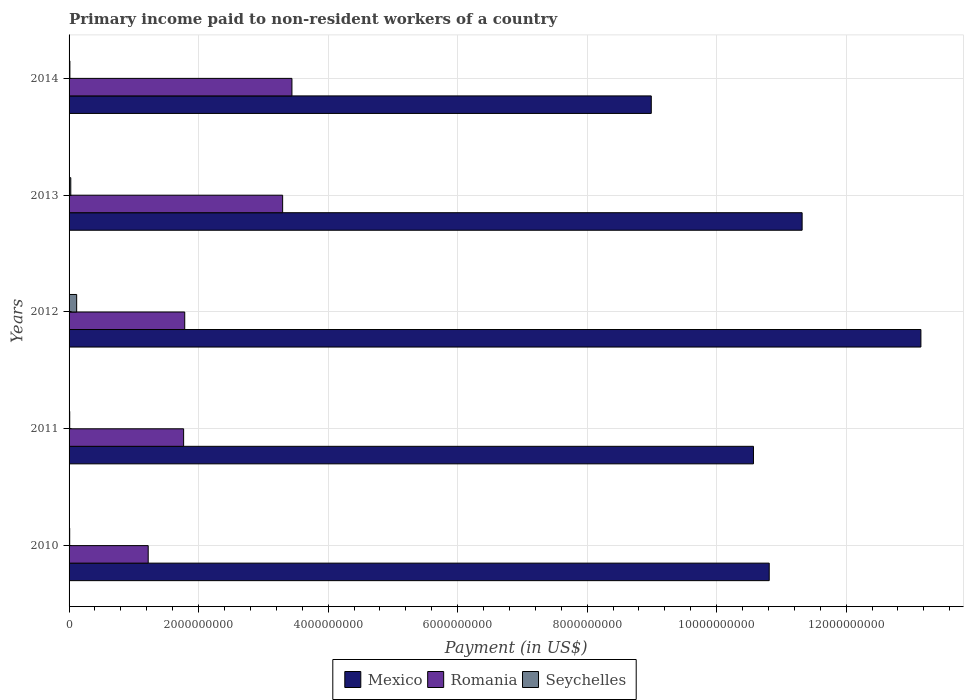How many different coloured bars are there?
Give a very brief answer. 3. How many groups of bars are there?
Offer a terse response. 5. Are the number of bars per tick equal to the number of legend labels?
Offer a very short reply. Yes. Are the number of bars on each tick of the Y-axis equal?
Make the answer very short. Yes. How many bars are there on the 1st tick from the top?
Provide a short and direct response. 3. How many bars are there on the 2nd tick from the bottom?
Offer a terse response. 3. What is the amount paid to workers in Seychelles in 2013?
Provide a succinct answer. 2.65e+07. Across all years, what is the maximum amount paid to workers in Mexico?
Offer a very short reply. 1.32e+1. Across all years, what is the minimum amount paid to workers in Mexico?
Make the answer very short. 8.99e+09. In which year was the amount paid to workers in Seychelles minimum?
Give a very brief answer. 2010. What is the total amount paid to workers in Seychelles in the graph?
Your answer should be very brief. 1.76e+08. What is the difference between the amount paid to workers in Romania in 2010 and that in 2012?
Offer a terse response. -5.64e+08. What is the difference between the amount paid to workers in Romania in 2010 and the amount paid to workers in Mexico in 2011?
Offer a terse response. -9.35e+09. What is the average amount paid to workers in Romania per year?
Your answer should be compact. 2.30e+09. In the year 2014, what is the difference between the amount paid to workers in Seychelles and amount paid to workers in Romania?
Provide a short and direct response. -3.43e+09. What is the ratio of the amount paid to workers in Mexico in 2011 to that in 2012?
Offer a terse response. 0.8. Is the amount paid to workers in Mexico in 2010 less than that in 2013?
Your answer should be very brief. Yes. What is the difference between the highest and the second highest amount paid to workers in Romania?
Offer a very short reply. 1.44e+08. What is the difference between the highest and the lowest amount paid to workers in Seychelles?
Give a very brief answer. 1.08e+08. Is the sum of the amount paid to workers in Mexico in 2010 and 2013 greater than the maximum amount paid to workers in Seychelles across all years?
Your response must be concise. Yes. What does the 2nd bar from the bottom in 2013 represents?
Keep it short and to the point. Romania. How many years are there in the graph?
Provide a short and direct response. 5. What is the difference between two consecutive major ticks on the X-axis?
Keep it short and to the point. 2.00e+09. Does the graph contain grids?
Give a very brief answer. Yes. How are the legend labels stacked?
Provide a short and direct response. Horizontal. What is the title of the graph?
Make the answer very short. Primary income paid to non-resident workers of a country. What is the label or title of the X-axis?
Your answer should be compact. Payment (in US$). What is the label or title of the Y-axis?
Offer a very short reply. Years. What is the Payment (in US$) of Mexico in 2010?
Make the answer very short. 1.08e+1. What is the Payment (in US$) in Romania in 2010?
Offer a very short reply. 1.22e+09. What is the Payment (in US$) in Seychelles in 2010?
Your answer should be compact. 9.57e+06. What is the Payment (in US$) of Mexico in 2011?
Your answer should be compact. 1.06e+1. What is the Payment (in US$) of Romania in 2011?
Your answer should be very brief. 1.77e+09. What is the Payment (in US$) in Seychelles in 2011?
Your answer should be compact. 9.97e+06. What is the Payment (in US$) of Mexico in 2012?
Provide a short and direct response. 1.32e+1. What is the Payment (in US$) of Romania in 2012?
Make the answer very short. 1.79e+09. What is the Payment (in US$) of Seychelles in 2012?
Provide a short and direct response. 1.17e+08. What is the Payment (in US$) of Mexico in 2013?
Ensure brevity in your answer.  1.13e+1. What is the Payment (in US$) of Romania in 2013?
Ensure brevity in your answer.  3.30e+09. What is the Payment (in US$) of Seychelles in 2013?
Your answer should be very brief. 2.65e+07. What is the Payment (in US$) of Mexico in 2014?
Provide a succinct answer. 8.99e+09. What is the Payment (in US$) in Romania in 2014?
Make the answer very short. 3.44e+09. What is the Payment (in US$) in Seychelles in 2014?
Make the answer very short. 1.26e+07. Across all years, what is the maximum Payment (in US$) in Mexico?
Your answer should be very brief. 1.32e+1. Across all years, what is the maximum Payment (in US$) in Romania?
Your response must be concise. 3.44e+09. Across all years, what is the maximum Payment (in US$) of Seychelles?
Your answer should be compact. 1.17e+08. Across all years, what is the minimum Payment (in US$) of Mexico?
Your response must be concise. 8.99e+09. Across all years, what is the minimum Payment (in US$) in Romania?
Provide a succinct answer. 1.22e+09. Across all years, what is the minimum Payment (in US$) in Seychelles?
Make the answer very short. 9.57e+06. What is the total Payment (in US$) in Mexico in the graph?
Ensure brevity in your answer.  5.48e+1. What is the total Payment (in US$) in Romania in the graph?
Keep it short and to the point. 1.15e+1. What is the total Payment (in US$) in Seychelles in the graph?
Your answer should be very brief. 1.76e+08. What is the difference between the Payment (in US$) in Mexico in 2010 and that in 2011?
Give a very brief answer. 2.43e+08. What is the difference between the Payment (in US$) in Romania in 2010 and that in 2011?
Keep it short and to the point. -5.47e+08. What is the difference between the Payment (in US$) of Seychelles in 2010 and that in 2011?
Make the answer very short. -4.01e+05. What is the difference between the Payment (in US$) in Mexico in 2010 and that in 2012?
Give a very brief answer. -2.34e+09. What is the difference between the Payment (in US$) of Romania in 2010 and that in 2012?
Offer a terse response. -5.64e+08. What is the difference between the Payment (in US$) of Seychelles in 2010 and that in 2012?
Make the answer very short. -1.08e+08. What is the difference between the Payment (in US$) of Mexico in 2010 and that in 2013?
Provide a short and direct response. -5.08e+08. What is the difference between the Payment (in US$) in Romania in 2010 and that in 2013?
Make the answer very short. -2.08e+09. What is the difference between the Payment (in US$) in Seychelles in 2010 and that in 2013?
Make the answer very short. -1.69e+07. What is the difference between the Payment (in US$) in Mexico in 2010 and that in 2014?
Provide a succinct answer. 1.82e+09. What is the difference between the Payment (in US$) in Romania in 2010 and that in 2014?
Your answer should be very brief. -2.22e+09. What is the difference between the Payment (in US$) in Seychelles in 2010 and that in 2014?
Offer a terse response. -3.07e+06. What is the difference between the Payment (in US$) in Mexico in 2011 and that in 2012?
Your answer should be very brief. -2.59e+09. What is the difference between the Payment (in US$) of Romania in 2011 and that in 2012?
Ensure brevity in your answer.  -1.70e+07. What is the difference between the Payment (in US$) of Seychelles in 2011 and that in 2012?
Ensure brevity in your answer.  -1.07e+08. What is the difference between the Payment (in US$) in Mexico in 2011 and that in 2013?
Provide a succinct answer. -7.51e+08. What is the difference between the Payment (in US$) in Romania in 2011 and that in 2013?
Provide a short and direct response. -1.53e+09. What is the difference between the Payment (in US$) of Seychelles in 2011 and that in 2013?
Your answer should be very brief. -1.65e+07. What is the difference between the Payment (in US$) of Mexico in 2011 and that in 2014?
Make the answer very short. 1.58e+09. What is the difference between the Payment (in US$) of Romania in 2011 and that in 2014?
Your answer should be compact. -1.67e+09. What is the difference between the Payment (in US$) of Seychelles in 2011 and that in 2014?
Offer a terse response. -2.67e+06. What is the difference between the Payment (in US$) in Mexico in 2012 and that in 2013?
Provide a succinct answer. 1.83e+09. What is the difference between the Payment (in US$) in Romania in 2012 and that in 2013?
Keep it short and to the point. -1.51e+09. What is the difference between the Payment (in US$) of Seychelles in 2012 and that in 2013?
Your response must be concise. 9.10e+07. What is the difference between the Payment (in US$) in Mexico in 2012 and that in 2014?
Provide a short and direct response. 4.16e+09. What is the difference between the Payment (in US$) of Romania in 2012 and that in 2014?
Your response must be concise. -1.66e+09. What is the difference between the Payment (in US$) in Seychelles in 2012 and that in 2014?
Offer a very short reply. 1.05e+08. What is the difference between the Payment (in US$) in Mexico in 2013 and that in 2014?
Your answer should be very brief. 2.33e+09. What is the difference between the Payment (in US$) in Romania in 2013 and that in 2014?
Offer a terse response. -1.44e+08. What is the difference between the Payment (in US$) in Seychelles in 2013 and that in 2014?
Offer a very short reply. 1.39e+07. What is the difference between the Payment (in US$) in Mexico in 2010 and the Payment (in US$) in Romania in 2011?
Keep it short and to the point. 9.04e+09. What is the difference between the Payment (in US$) in Mexico in 2010 and the Payment (in US$) in Seychelles in 2011?
Provide a succinct answer. 1.08e+1. What is the difference between the Payment (in US$) of Romania in 2010 and the Payment (in US$) of Seychelles in 2011?
Your response must be concise. 1.21e+09. What is the difference between the Payment (in US$) in Mexico in 2010 and the Payment (in US$) in Romania in 2012?
Your answer should be compact. 9.03e+09. What is the difference between the Payment (in US$) in Mexico in 2010 and the Payment (in US$) in Seychelles in 2012?
Give a very brief answer. 1.07e+1. What is the difference between the Payment (in US$) of Romania in 2010 and the Payment (in US$) of Seychelles in 2012?
Keep it short and to the point. 1.10e+09. What is the difference between the Payment (in US$) in Mexico in 2010 and the Payment (in US$) in Romania in 2013?
Your response must be concise. 7.51e+09. What is the difference between the Payment (in US$) in Mexico in 2010 and the Payment (in US$) in Seychelles in 2013?
Provide a succinct answer. 1.08e+1. What is the difference between the Payment (in US$) in Romania in 2010 and the Payment (in US$) in Seychelles in 2013?
Your answer should be very brief. 1.20e+09. What is the difference between the Payment (in US$) of Mexico in 2010 and the Payment (in US$) of Romania in 2014?
Your answer should be compact. 7.37e+09. What is the difference between the Payment (in US$) of Mexico in 2010 and the Payment (in US$) of Seychelles in 2014?
Ensure brevity in your answer.  1.08e+1. What is the difference between the Payment (in US$) in Romania in 2010 and the Payment (in US$) in Seychelles in 2014?
Provide a succinct answer. 1.21e+09. What is the difference between the Payment (in US$) in Mexico in 2011 and the Payment (in US$) in Romania in 2012?
Ensure brevity in your answer.  8.78e+09. What is the difference between the Payment (in US$) in Mexico in 2011 and the Payment (in US$) in Seychelles in 2012?
Offer a terse response. 1.05e+1. What is the difference between the Payment (in US$) in Romania in 2011 and the Payment (in US$) in Seychelles in 2012?
Provide a succinct answer. 1.65e+09. What is the difference between the Payment (in US$) of Mexico in 2011 and the Payment (in US$) of Romania in 2013?
Provide a short and direct response. 7.27e+09. What is the difference between the Payment (in US$) in Mexico in 2011 and the Payment (in US$) in Seychelles in 2013?
Offer a terse response. 1.05e+1. What is the difference between the Payment (in US$) in Romania in 2011 and the Payment (in US$) in Seychelles in 2013?
Your answer should be very brief. 1.74e+09. What is the difference between the Payment (in US$) of Mexico in 2011 and the Payment (in US$) of Romania in 2014?
Ensure brevity in your answer.  7.13e+09. What is the difference between the Payment (in US$) in Mexico in 2011 and the Payment (in US$) in Seychelles in 2014?
Your answer should be compact. 1.06e+1. What is the difference between the Payment (in US$) in Romania in 2011 and the Payment (in US$) in Seychelles in 2014?
Provide a succinct answer. 1.76e+09. What is the difference between the Payment (in US$) in Mexico in 2012 and the Payment (in US$) in Romania in 2013?
Keep it short and to the point. 9.86e+09. What is the difference between the Payment (in US$) of Mexico in 2012 and the Payment (in US$) of Seychelles in 2013?
Provide a succinct answer. 1.31e+1. What is the difference between the Payment (in US$) of Romania in 2012 and the Payment (in US$) of Seychelles in 2013?
Offer a very short reply. 1.76e+09. What is the difference between the Payment (in US$) in Mexico in 2012 and the Payment (in US$) in Romania in 2014?
Your response must be concise. 9.71e+09. What is the difference between the Payment (in US$) in Mexico in 2012 and the Payment (in US$) in Seychelles in 2014?
Provide a succinct answer. 1.31e+1. What is the difference between the Payment (in US$) in Romania in 2012 and the Payment (in US$) in Seychelles in 2014?
Offer a very short reply. 1.77e+09. What is the difference between the Payment (in US$) in Mexico in 2013 and the Payment (in US$) in Romania in 2014?
Your response must be concise. 7.88e+09. What is the difference between the Payment (in US$) of Mexico in 2013 and the Payment (in US$) of Seychelles in 2014?
Give a very brief answer. 1.13e+1. What is the difference between the Payment (in US$) in Romania in 2013 and the Payment (in US$) in Seychelles in 2014?
Your answer should be compact. 3.29e+09. What is the average Payment (in US$) of Mexico per year?
Provide a short and direct response. 1.10e+1. What is the average Payment (in US$) in Romania per year?
Offer a very short reply. 2.30e+09. What is the average Payment (in US$) of Seychelles per year?
Make the answer very short. 3.52e+07. In the year 2010, what is the difference between the Payment (in US$) in Mexico and Payment (in US$) in Romania?
Provide a succinct answer. 9.59e+09. In the year 2010, what is the difference between the Payment (in US$) of Mexico and Payment (in US$) of Seychelles?
Ensure brevity in your answer.  1.08e+1. In the year 2010, what is the difference between the Payment (in US$) in Romania and Payment (in US$) in Seychelles?
Your answer should be very brief. 1.21e+09. In the year 2011, what is the difference between the Payment (in US$) of Mexico and Payment (in US$) of Romania?
Offer a very short reply. 8.80e+09. In the year 2011, what is the difference between the Payment (in US$) of Mexico and Payment (in US$) of Seychelles?
Your response must be concise. 1.06e+1. In the year 2011, what is the difference between the Payment (in US$) in Romania and Payment (in US$) in Seychelles?
Your response must be concise. 1.76e+09. In the year 2012, what is the difference between the Payment (in US$) of Mexico and Payment (in US$) of Romania?
Offer a terse response. 1.14e+1. In the year 2012, what is the difference between the Payment (in US$) in Mexico and Payment (in US$) in Seychelles?
Your response must be concise. 1.30e+1. In the year 2012, what is the difference between the Payment (in US$) of Romania and Payment (in US$) of Seychelles?
Your response must be concise. 1.67e+09. In the year 2013, what is the difference between the Payment (in US$) of Mexico and Payment (in US$) of Romania?
Provide a short and direct response. 8.02e+09. In the year 2013, what is the difference between the Payment (in US$) of Mexico and Payment (in US$) of Seychelles?
Make the answer very short. 1.13e+1. In the year 2013, what is the difference between the Payment (in US$) of Romania and Payment (in US$) of Seychelles?
Keep it short and to the point. 3.27e+09. In the year 2014, what is the difference between the Payment (in US$) of Mexico and Payment (in US$) of Romania?
Provide a short and direct response. 5.55e+09. In the year 2014, what is the difference between the Payment (in US$) of Mexico and Payment (in US$) of Seychelles?
Ensure brevity in your answer.  8.98e+09. In the year 2014, what is the difference between the Payment (in US$) of Romania and Payment (in US$) of Seychelles?
Keep it short and to the point. 3.43e+09. What is the ratio of the Payment (in US$) of Mexico in 2010 to that in 2011?
Make the answer very short. 1.02. What is the ratio of the Payment (in US$) of Romania in 2010 to that in 2011?
Your response must be concise. 0.69. What is the ratio of the Payment (in US$) of Seychelles in 2010 to that in 2011?
Keep it short and to the point. 0.96. What is the ratio of the Payment (in US$) in Mexico in 2010 to that in 2012?
Keep it short and to the point. 0.82. What is the ratio of the Payment (in US$) in Romania in 2010 to that in 2012?
Your answer should be compact. 0.68. What is the ratio of the Payment (in US$) in Seychelles in 2010 to that in 2012?
Provide a short and direct response. 0.08. What is the ratio of the Payment (in US$) of Mexico in 2010 to that in 2013?
Provide a short and direct response. 0.96. What is the ratio of the Payment (in US$) of Romania in 2010 to that in 2013?
Offer a very short reply. 0.37. What is the ratio of the Payment (in US$) in Seychelles in 2010 to that in 2013?
Make the answer very short. 0.36. What is the ratio of the Payment (in US$) in Mexico in 2010 to that in 2014?
Offer a very short reply. 1.2. What is the ratio of the Payment (in US$) in Romania in 2010 to that in 2014?
Offer a terse response. 0.36. What is the ratio of the Payment (in US$) in Seychelles in 2010 to that in 2014?
Give a very brief answer. 0.76. What is the ratio of the Payment (in US$) in Mexico in 2011 to that in 2012?
Provide a short and direct response. 0.8. What is the ratio of the Payment (in US$) of Romania in 2011 to that in 2012?
Provide a short and direct response. 0.99. What is the ratio of the Payment (in US$) in Seychelles in 2011 to that in 2012?
Keep it short and to the point. 0.08. What is the ratio of the Payment (in US$) in Mexico in 2011 to that in 2013?
Provide a succinct answer. 0.93. What is the ratio of the Payment (in US$) in Romania in 2011 to that in 2013?
Provide a succinct answer. 0.54. What is the ratio of the Payment (in US$) in Seychelles in 2011 to that in 2013?
Keep it short and to the point. 0.38. What is the ratio of the Payment (in US$) of Mexico in 2011 to that in 2014?
Provide a short and direct response. 1.18. What is the ratio of the Payment (in US$) of Romania in 2011 to that in 2014?
Your answer should be compact. 0.51. What is the ratio of the Payment (in US$) in Seychelles in 2011 to that in 2014?
Make the answer very short. 0.79. What is the ratio of the Payment (in US$) of Mexico in 2012 to that in 2013?
Keep it short and to the point. 1.16. What is the ratio of the Payment (in US$) of Romania in 2012 to that in 2013?
Offer a very short reply. 0.54. What is the ratio of the Payment (in US$) in Seychelles in 2012 to that in 2013?
Give a very brief answer. 4.43. What is the ratio of the Payment (in US$) in Mexico in 2012 to that in 2014?
Offer a terse response. 1.46. What is the ratio of the Payment (in US$) of Romania in 2012 to that in 2014?
Offer a very short reply. 0.52. What is the ratio of the Payment (in US$) in Seychelles in 2012 to that in 2014?
Your response must be concise. 9.29. What is the ratio of the Payment (in US$) in Mexico in 2013 to that in 2014?
Keep it short and to the point. 1.26. What is the ratio of the Payment (in US$) in Romania in 2013 to that in 2014?
Ensure brevity in your answer.  0.96. What is the ratio of the Payment (in US$) in Seychelles in 2013 to that in 2014?
Your answer should be very brief. 2.1. What is the difference between the highest and the second highest Payment (in US$) in Mexico?
Provide a short and direct response. 1.83e+09. What is the difference between the highest and the second highest Payment (in US$) of Romania?
Offer a very short reply. 1.44e+08. What is the difference between the highest and the second highest Payment (in US$) in Seychelles?
Provide a short and direct response. 9.10e+07. What is the difference between the highest and the lowest Payment (in US$) of Mexico?
Provide a short and direct response. 4.16e+09. What is the difference between the highest and the lowest Payment (in US$) in Romania?
Ensure brevity in your answer.  2.22e+09. What is the difference between the highest and the lowest Payment (in US$) in Seychelles?
Provide a succinct answer. 1.08e+08. 